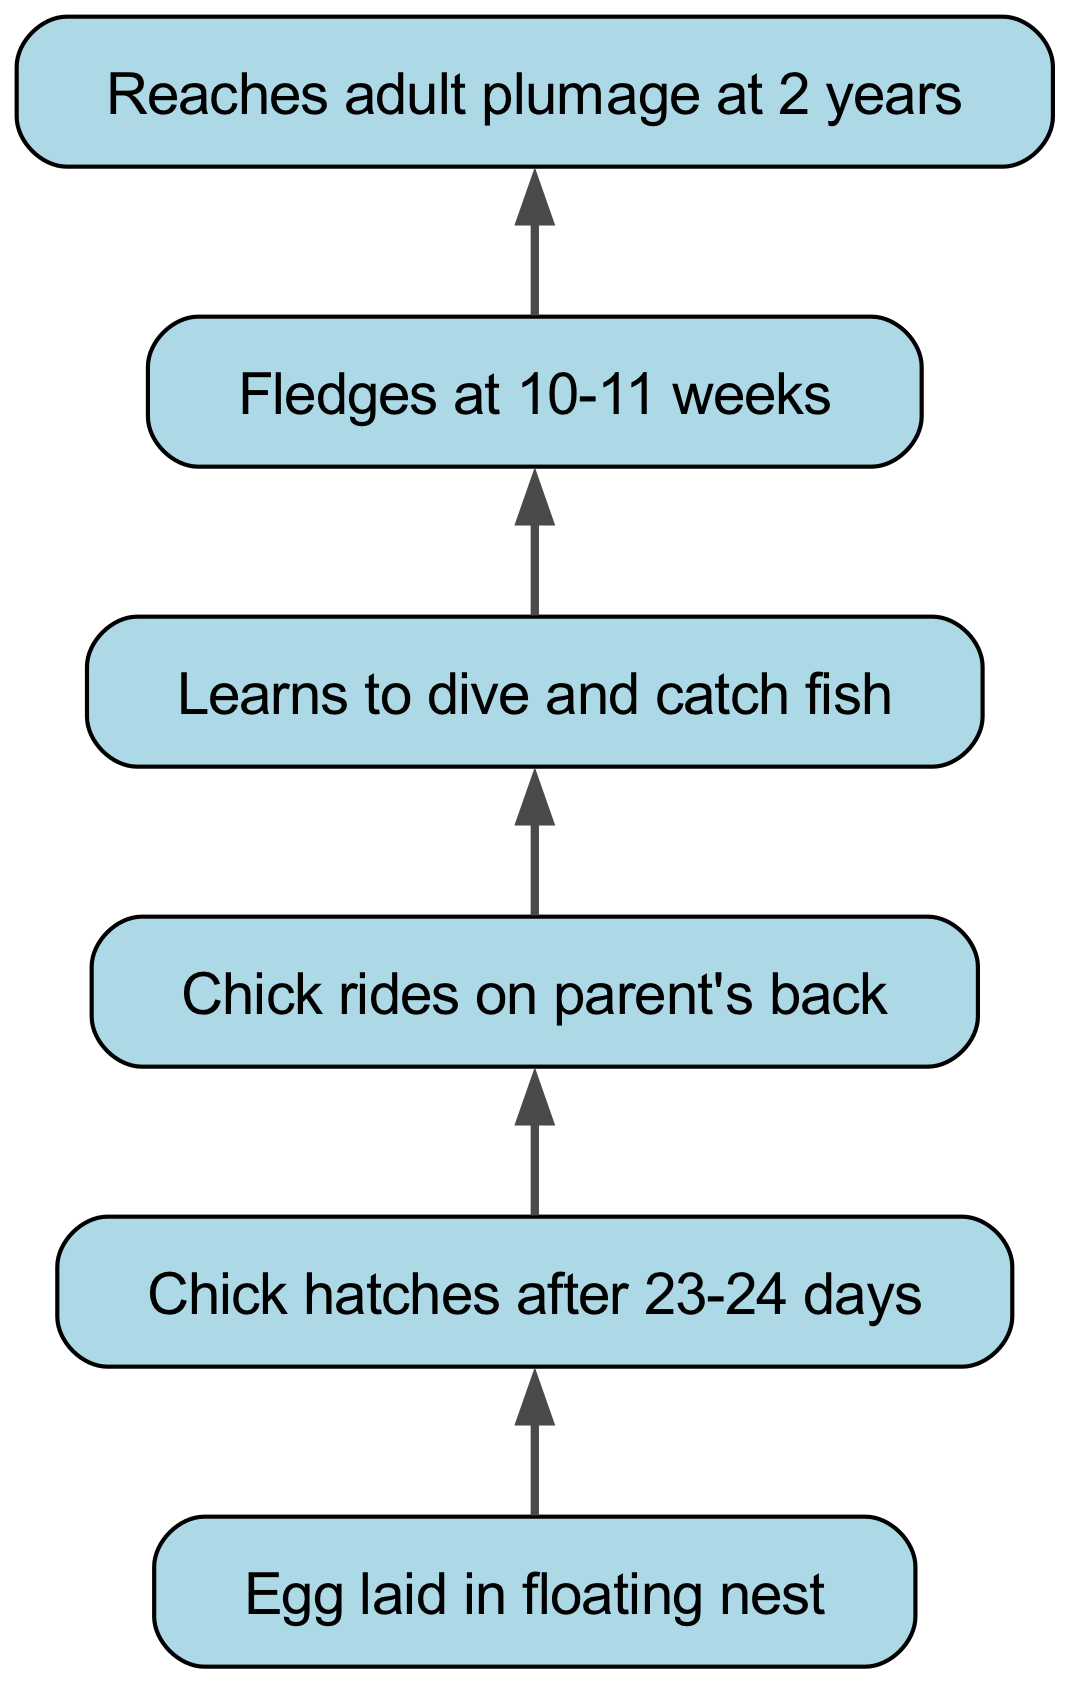What is the starting point of the Western Grebe's life cycle? The diagram indicates that the life cycle begins with the node labeled "Egg laid in floating nest." As the first node, it serves as the foundation for the entire flow chart.
Answer: Egg laid in floating nest How many nodes are there in total? Counting each individual step represented in the diagram reveals a total of six nodes: Egg, Hatch, Ride, Dive, Fledge, and Adult.
Answer: 6 What event occurs after the chick hatches? Following the "Chick hatches after 23-24 days" node, the next step according to the chart is "Chick rides on parent's back." This indicates the immediate succession of events in the life cycle.
Answer: Chick rides on parent's back At what age does a Western Grebe fledge? Referring to the node labeled "Fledges at 10-11 weeks," we can conclude that the fledging occurs when the chick reaches this specific age range.
Answer: 10-11 weeks What stages are directly connected to the diving ability? The diagram shows that the "Learns to dive and catch fish" stage follows the "Chick rides on parent's back." Therefore, the stages connected to diving are "Ride" and "Dive."
Answer: Ride and Dive How long does it take for the egg to hatch? By examining the node titled "Chick hatches after 23-24 days," we find that the time span specified is between 23 and 24 days for the egg to hatch.
Answer: 23-24 days What is the final stage in the life cycle of a Western Grebe? The last node in the flow chart, labeled "Reaches adult plumage at 2 years," indicates that this stage represents the culmination of the life cycle for the Western Grebe.
Answer: Reaches adult plumage at 2 years What does the chick do to learn how to catch fish? According to the flow chart, the chick learns to catch fish during the "Learns to dive and catch fish" stage after it has been riding on its parent's back.
Answer: Learns to dive and catch fish Which stage represents a form of parental care? The "Chick rides on parent's back" node symbolizes a form of parental care where the chick relies on its parent for transportation and protection during its early development.
Answer: Chick rides on parent's back 